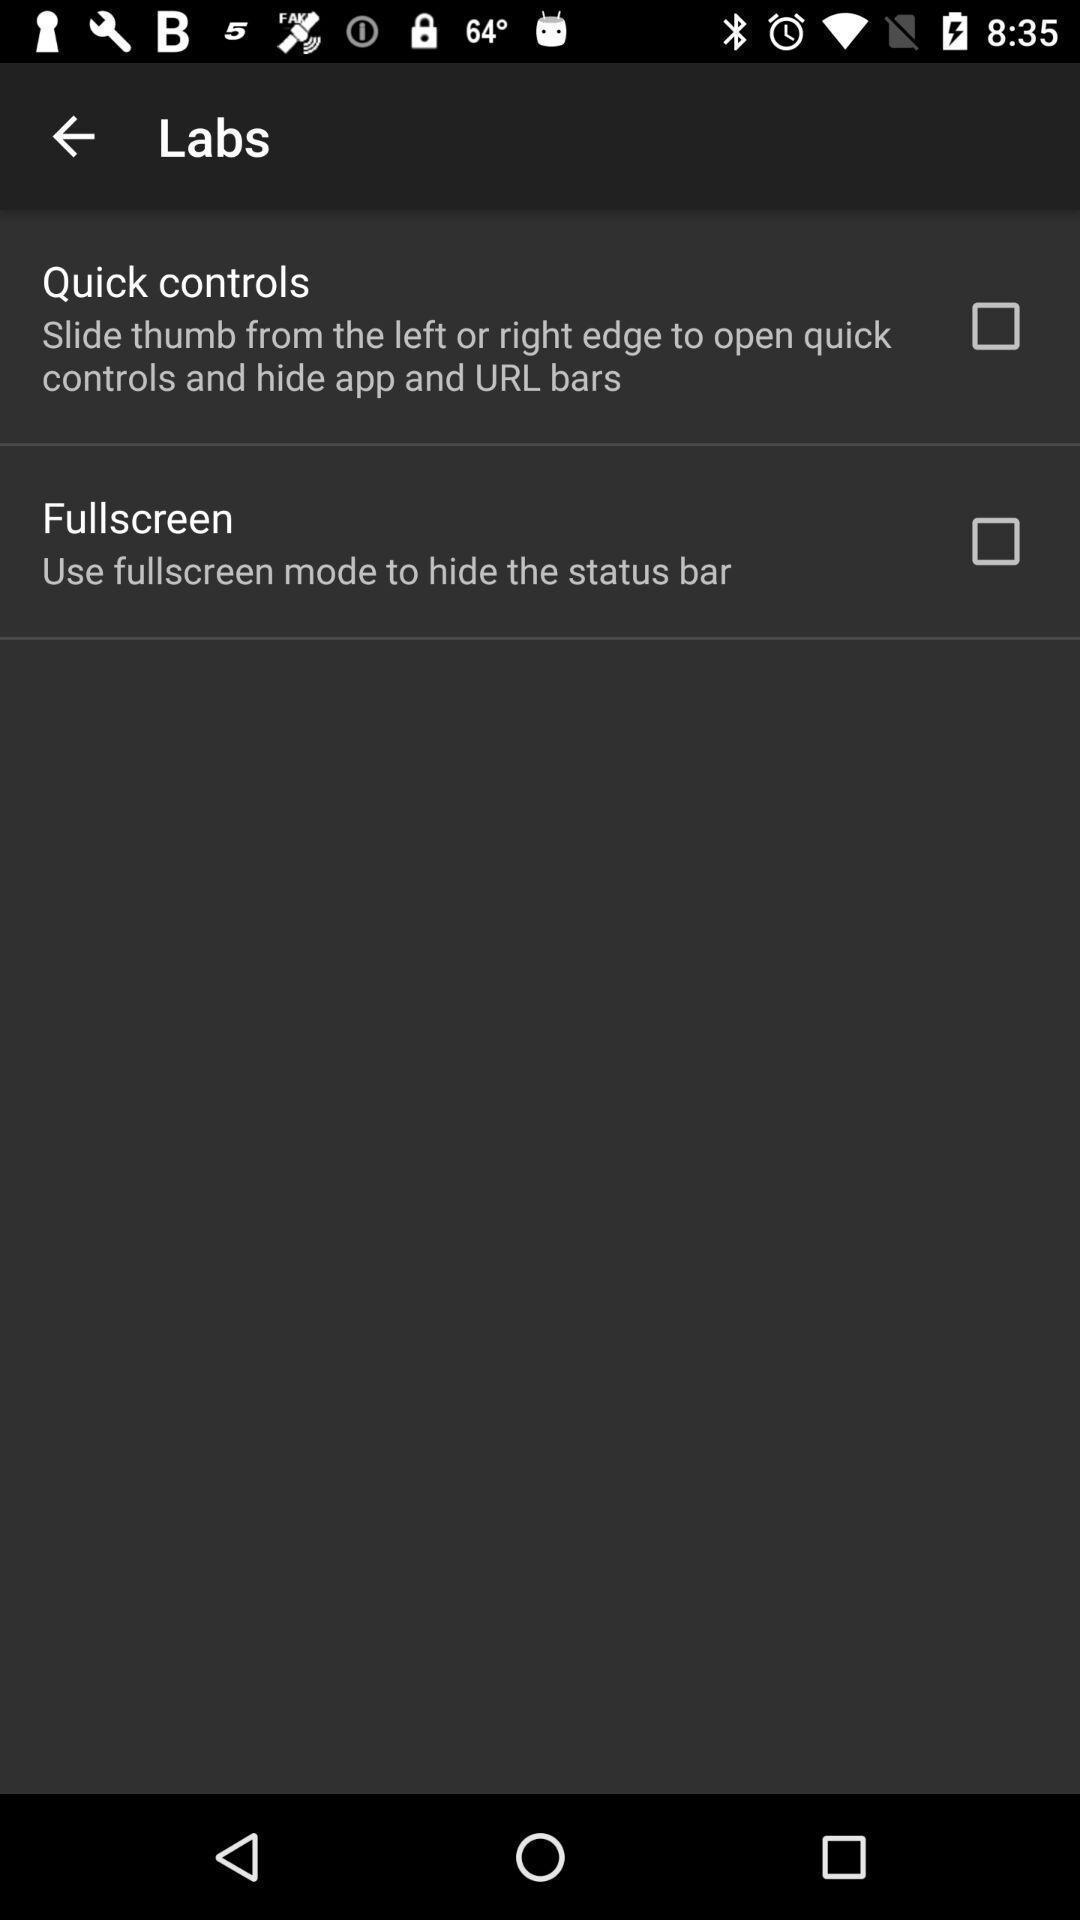Summarize the main components in this picture. Settings page. 